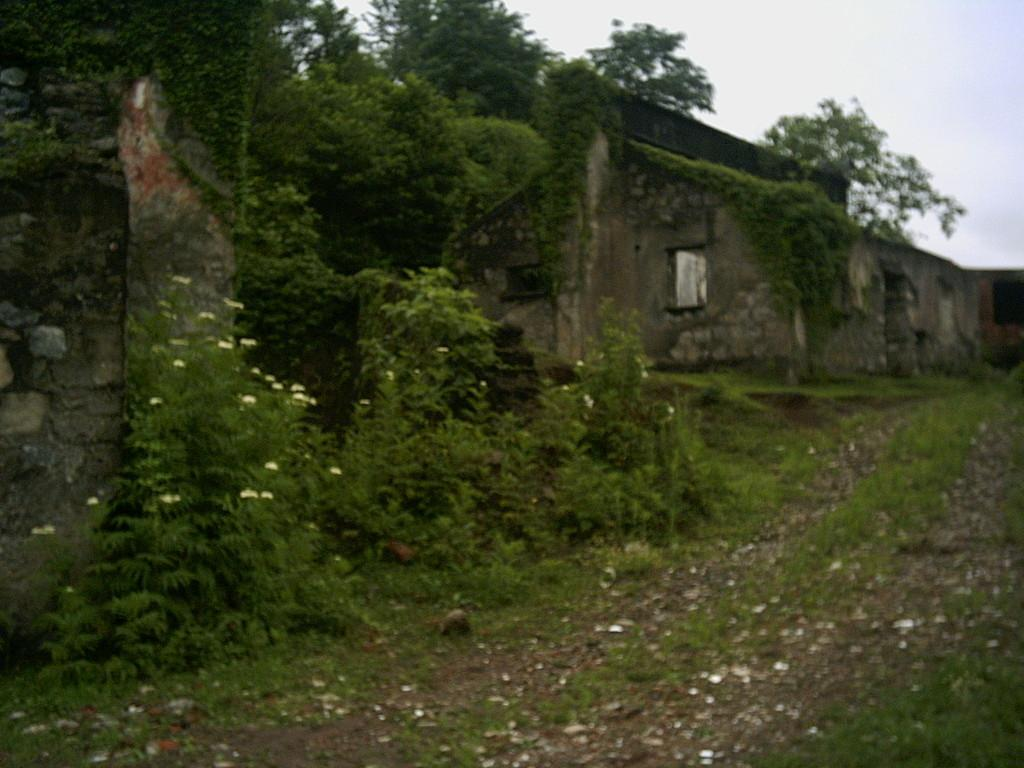What type of structures are present in the image? There are old buildings in the image. What other natural elements can be seen in the image? There are trees, plants, and flowers in the image. What type of ground surface is visible in the image? There are stones in the image. What is visible in the background of the image? The sky is visible in the image. What type of bomb can be seen in the image? There is no bomb present in the image. Can you hear the voice of the person in the image? There is no person present in the image, so it is not possible to hear their voice. 